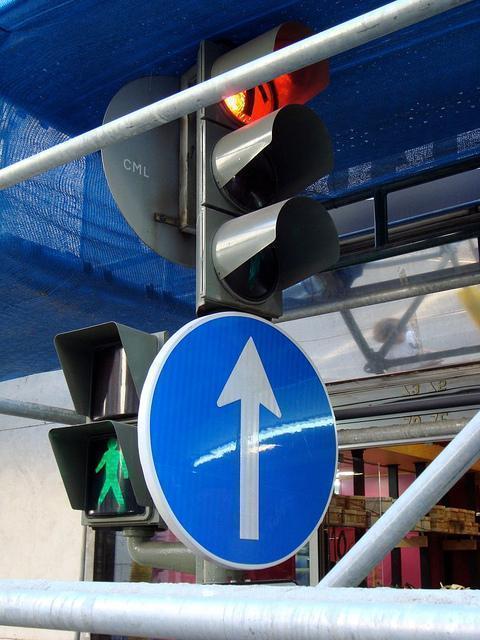What does the blue sign with a white arrow mean?
Choose the correct response, then elucidate: 'Answer: answer
Rationale: rationale.'
Options: Ahead only, parking, stop, no turns. Answer: ahead only.
Rationale: It might also mean b depending on the location, but typically it just means a. 